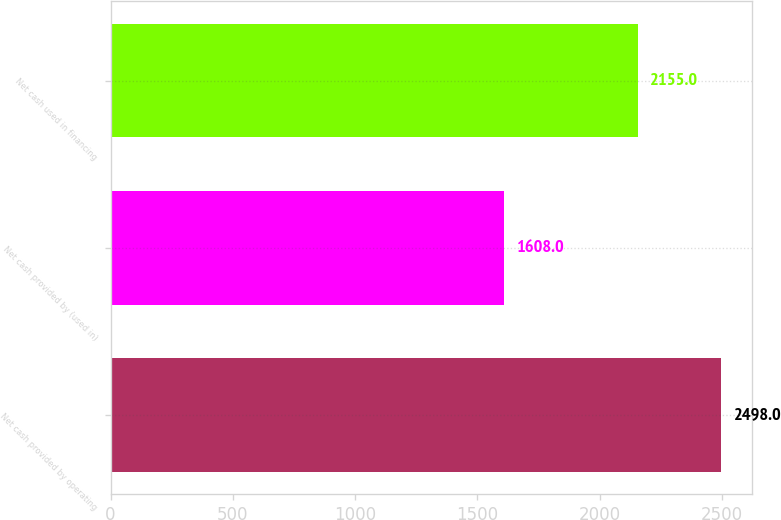Convert chart. <chart><loc_0><loc_0><loc_500><loc_500><bar_chart><fcel>Net cash provided by operating<fcel>Net cash provided by (used in)<fcel>Net cash used in financing<nl><fcel>2498<fcel>1608<fcel>2155<nl></chart> 